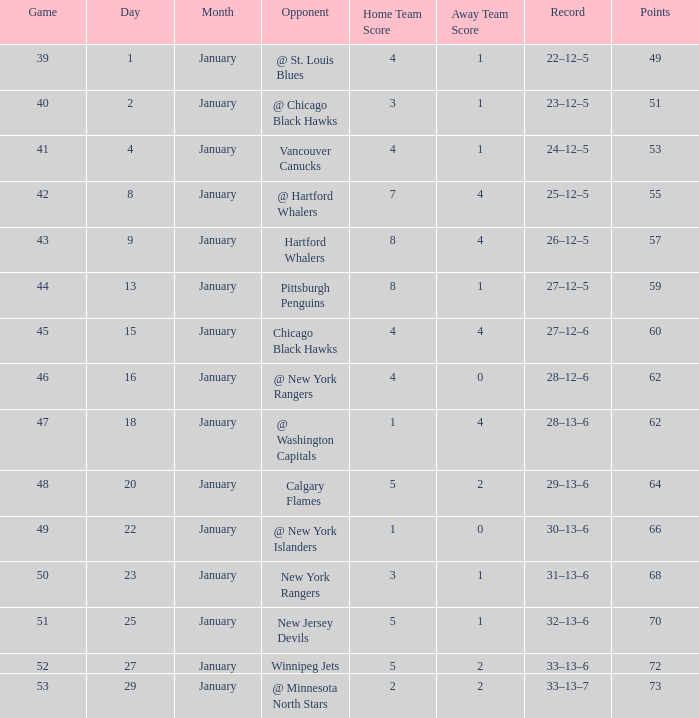How many games have a Score of 1–0, and Points smaller than 66? 0.0. 